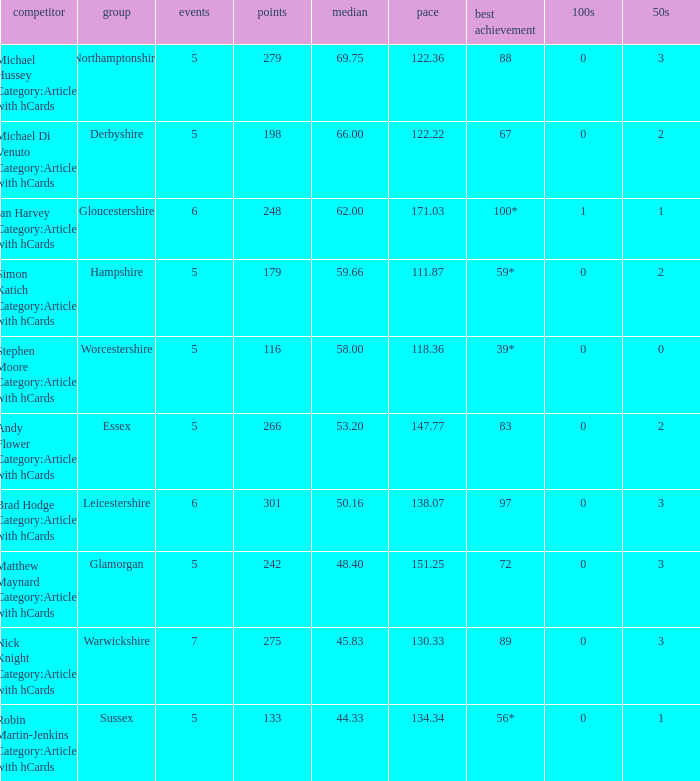Can you give me this table as a dict? {'header': ['competitor', 'group', 'events', 'points', 'median', 'pace', 'best achievement', '100s', '50s'], 'rows': [['Michael Hussey Category:Articles with hCards', 'Northamptonshire', '5', '279', '69.75', '122.36', '88', '0', '3'], ['Michael Di Venuto Category:Articles with hCards', 'Derbyshire', '5', '198', '66.00', '122.22', '67', '0', '2'], ['Ian Harvey Category:Articles with hCards', 'Gloucestershire', '6', '248', '62.00', '171.03', '100*', '1', '1'], ['Simon Katich Category:Articles with hCards', 'Hampshire', '5', '179', '59.66', '111.87', '59*', '0', '2'], ['Stephen Moore Category:Articles with hCards', 'Worcestershire', '5', '116', '58.00', '118.36', '39*', '0', '0'], ['Andy Flower Category:Articles with hCards', 'Essex', '5', '266', '53.20', '147.77', '83', '0', '2'], ['Brad Hodge Category:Articles with hCards', 'Leicestershire', '6', '301', '50.16', '138.07', '97', '0', '3'], ['Matthew Maynard Category:Articles with hCards', 'Glamorgan', '5', '242', '48.40', '151.25', '72', '0', '3'], ['Nick Knight Category:Articles with hCards', 'Warwickshire', '7', '275', '45.83', '130.33', '89', '0', '3'], ['Robin Martin-Jenkins Category:Articles with hCards', 'Sussex', '5', '133', '44.33', '134.34', '56*', '0', '1']]} If the average is 50.16, who is the player? Brad Hodge Category:Articles with hCards. 